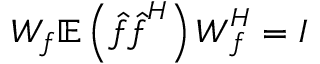<formula> <loc_0><loc_0><loc_500><loc_500>W _ { f } \mathbb { E } \left ( \hat { f } \hat { f } ^ { H } \right ) W _ { f } ^ { H } = I</formula> 